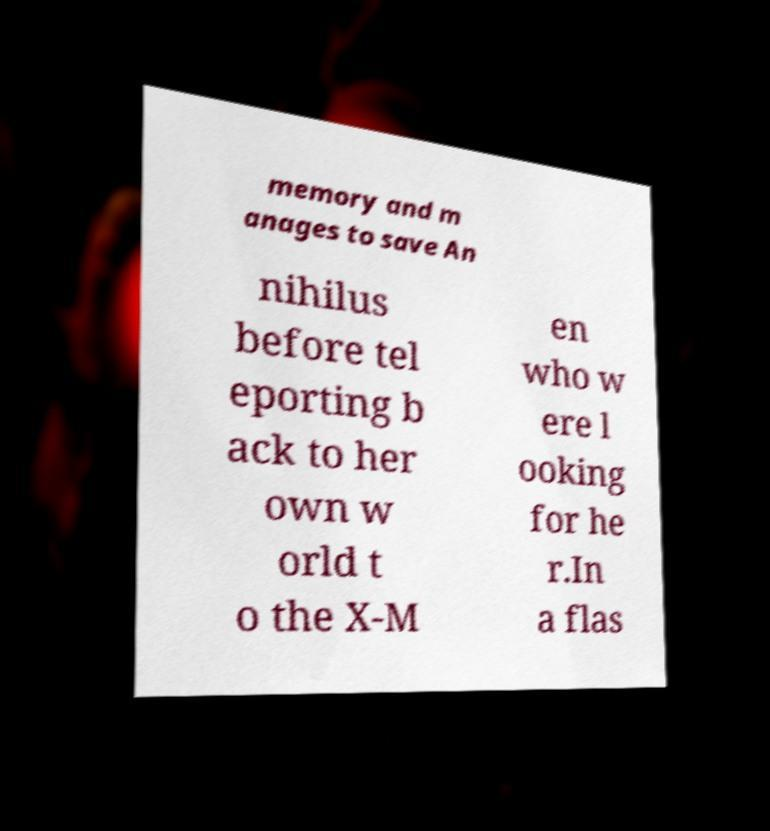I need the written content from this picture converted into text. Can you do that? memory and m anages to save An nihilus before tel eporting b ack to her own w orld t o the X-M en who w ere l ooking for he r.In a flas 